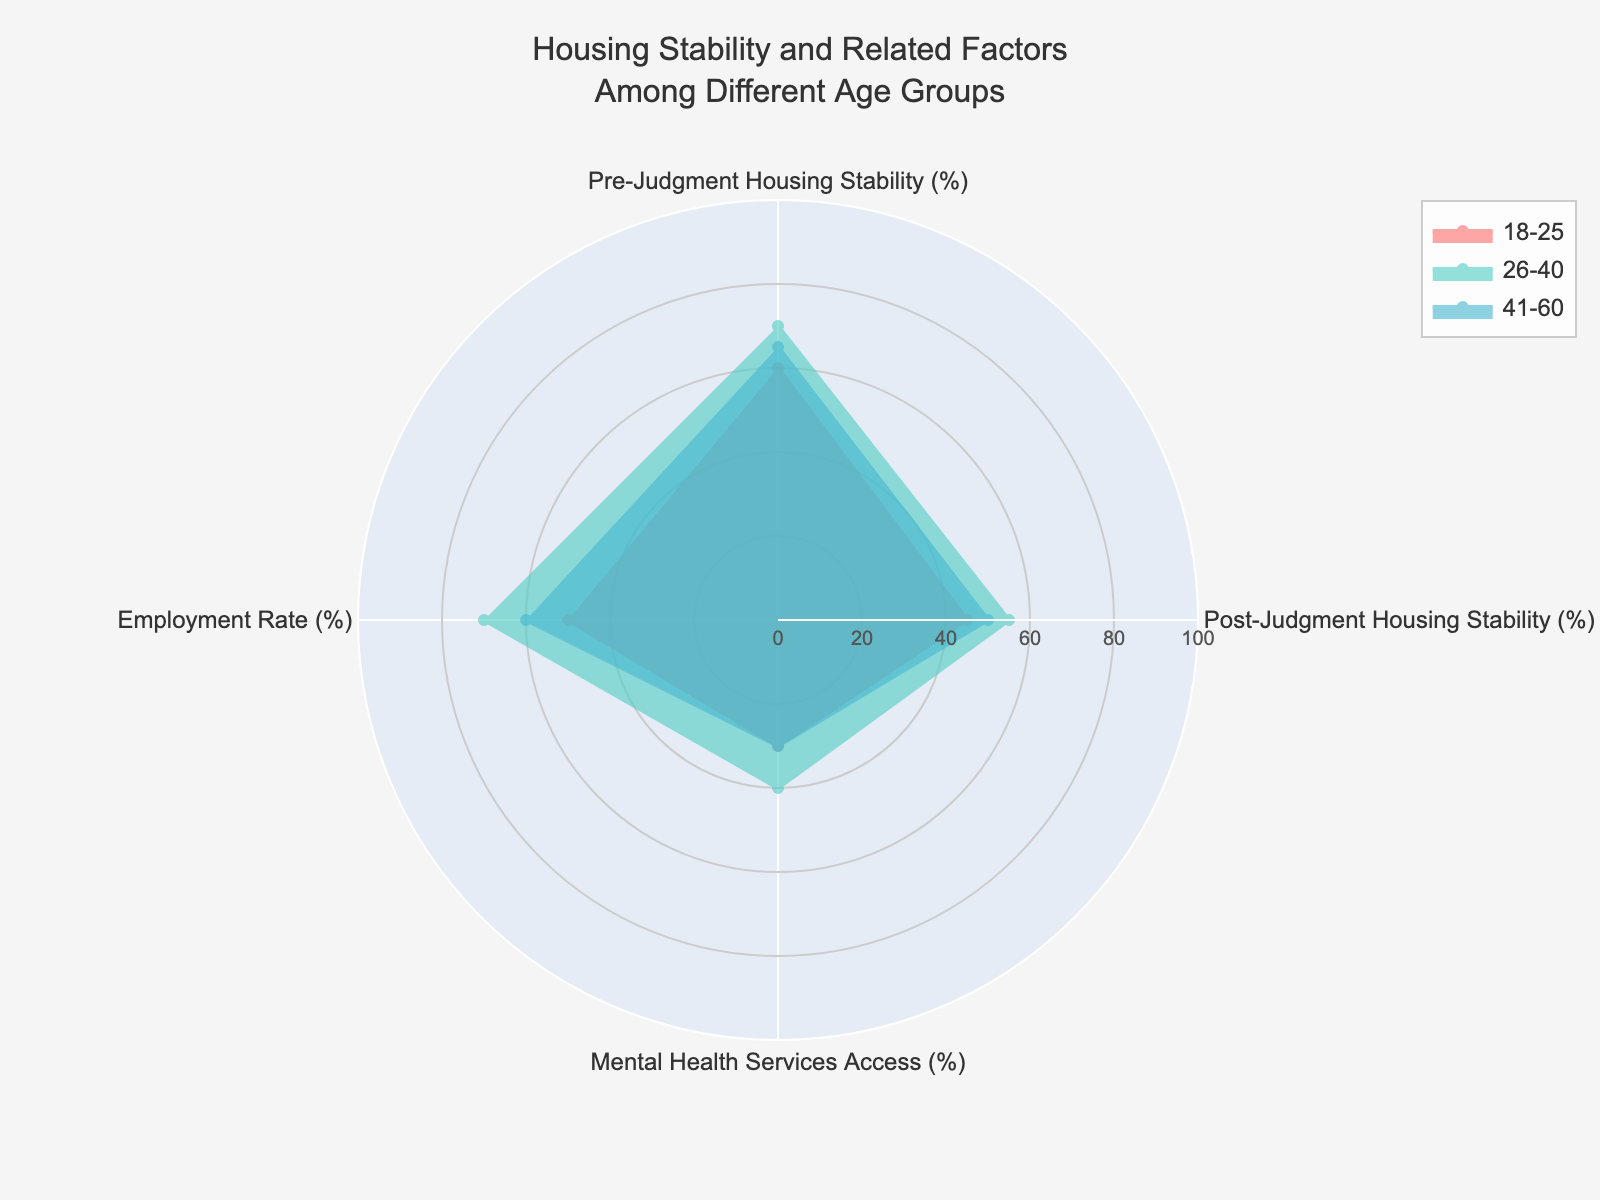What's the title of the figure? The title is usually found at the top of the chart; it provides a summary of what the figure represents. In this case, the title is displayed as "Housing Stability and Related Factors Among Different Age Groups".
Answer: Housing Stability and Related Factors Among Different Age Groups How many age groups are depicted in the radar chart? The radar chart includes different traces representing age groups. By checking the legend or the traces, we can see that there are three age groups represented.
Answer: 3 Which age group has the highest post-judgment housing stability? By examining the radar chart, we identify the post-judgment housing stability percentages for each age group. The '61+' age group has the largest area in this category.
Answer: 61+ Which category has the lowest employment rate among all displayed age groups? By looking at the radar chart and comparing the employment rates for all groups, the '61+' age group has the lowest employment rate at 30%.
Answer: 61+ How does the mental health services access rate for the 18-25 age group compare to the 41-60 age group? To compare these values, locate the mental health services access percentages for both age groups on the chart. The 18-25 group has 30%, and the 41-60 group also has 30%.
Answer: They are equal What is the difference in pre-judgment housing stability between the 26-40 and 18-25 age groups? Check the pre-judgment housing stability percentages for both age groups. For 26-40, it is 70%; for 18-25, it is 60%. Subtract 60 from 70.
Answer: 10% What's the average post-judgment housing stability among the 18-25, 26-40, and 41-60 age groups? Add the post-judgment housing stability percentages for these three age groups (45 + 55 + 50), then divide by 3 to find the average.
Answer: 50% Which age group shows the smallest decrease in housing stability from pre-judgment to post-judgment? Calculate the decrease for each age group: 
18-25: 60% - 45% = 15%, 
26-40: 70% - 55% = 15%, 
41-60: 65% - 50% = 15%. They all show the same decrease of 15%, so there is no single smallest.
Answer: All show the same decrease Among the categories shown, which one exhibits the largest value for the 61+ age group? Identify the largest value for the 61+ age group across all categories. The mental health services access is 50%, and it's higher compared to pre-judgment housing stability (75%), post-judgment housing stability (60%), and employment rate (30%). The highest in this group is pre-judgment housing stability.
Answer: Pre-judgment housing stability Which age group has the highest employment rate? Check the employment rate values for all age groups. The 26-40 age group will display the largest area in this category at 70%.
Answer: 26-40 